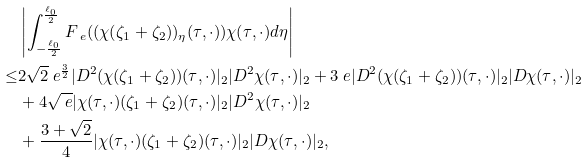Convert formula to latex. <formula><loc_0><loc_0><loc_500><loc_500>& \left | \int _ { - \frac { \ell _ { 0 } } { 2 } } ^ { \frac { \ell _ { 0 } } { 2 } } F _ { \ e } ( ( \chi ( \zeta _ { 1 } + \zeta _ { 2 } ) ) _ { \eta } ( \tau , \cdot ) ) \chi ( \tau , \cdot ) d \eta \right | \\ \leq & 2 \sqrt { 2 } \ e ^ { \frac { 3 } { 2 } } | D ^ { 2 } ( \chi ( \zeta _ { 1 } + \zeta _ { 2 } ) ) ( \tau , \cdot ) | _ { 2 } | D ^ { 2 } \chi ( \tau , \cdot ) | _ { 2 } + 3 \ e | D ^ { 2 } ( \chi ( \zeta _ { 1 } + \zeta _ { 2 } ) ) ( \tau , \cdot ) | _ { 2 } | D \chi ( \tau , \cdot ) | _ { 2 } \\ & + 4 \sqrt { \ e } | \chi ( \tau , \cdot ) ( \zeta _ { 1 } + \zeta _ { 2 } ) ( \tau , \cdot ) | _ { 2 } | D ^ { 2 } \chi ( \tau , \cdot ) | _ { 2 } \\ & + \frac { 3 + \sqrt { 2 } } { 4 } | \chi ( \tau , \cdot ) ( \zeta _ { 1 } + \zeta _ { 2 } ) ( \tau , \cdot ) | _ { 2 } | D \chi ( \tau , \cdot ) | _ { 2 } ,</formula> 